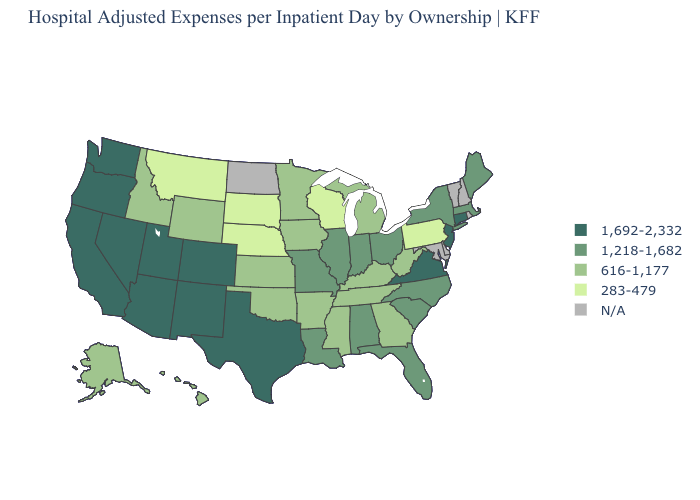Among the states that border West Virginia , does Virginia have the lowest value?
Keep it brief. No. Which states have the highest value in the USA?
Concise answer only. Arizona, California, Colorado, Connecticut, Nevada, New Jersey, New Mexico, Oregon, Texas, Utah, Virginia, Washington. Does the first symbol in the legend represent the smallest category?
Quick response, please. No. Which states hav the highest value in the Northeast?
Short answer required. Connecticut, New Jersey. Name the states that have a value in the range 616-1,177?
Quick response, please. Alaska, Arkansas, Georgia, Hawaii, Idaho, Iowa, Kansas, Kentucky, Michigan, Minnesota, Mississippi, Oklahoma, Tennessee, West Virginia, Wyoming. Which states hav the highest value in the West?
Keep it brief. Arizona, California, Colorado, Nevada, New Mexico, Oregon, Utah, Washington. Name the states that have a value in the range 1,692-2,332?
Answer briefly. Arizona, California, Colorado, Connecticut, Nevada, New Jersey, New Mexico, Oregon, Texas, Utah, Virginia, Washington. Among the states that border New Mexico , which have the highest value?
Give a very brief answer. Arizona, Colorado, Texas, Utah. Which states have the highest value in the USA?
Keep it brief. Arizona, California, Colorado, Connecticut, Nevada, New Jersey, New Mexico, Oregon, Texas, Utah, Virginia, Washington. What is the highest value in the USA?
Give a very brief answer. 1,692-2,332. What is the value of Wisconsin?
Give a very brief answer. 283-479. Name the states that have a value in the range 1,692-2,332?
Keep it brief. Arizona, California, Colorado, Connecticut, Nevada, New Jersey, New Mexico, Oregon, Texas, Utah, Virginia, Washington. Name the states that have a value in the range N/A?
Short answer required. Delaware, Maryland, New Hampshire, North Dakota, Rhode Island, Vermont. Name the states that have a value in the range 1,692-2,332?
Short answer required. Arizona, California, Colorado, Connecticut, Nevada, New Jersey, New Mexico, Oregon, Texas, Utah, Virginia, Washington. 